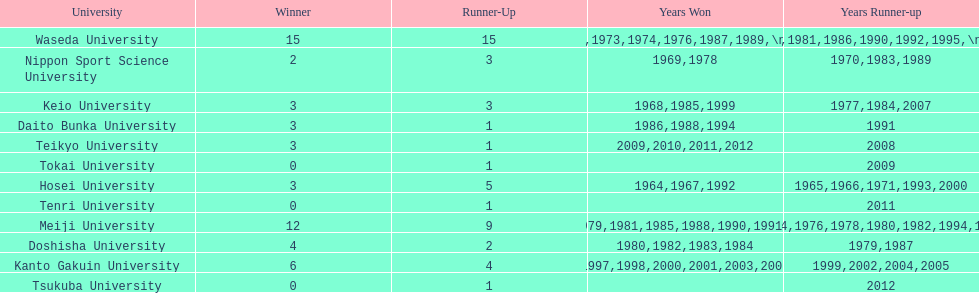Which university had the most years won? Waseda University. 